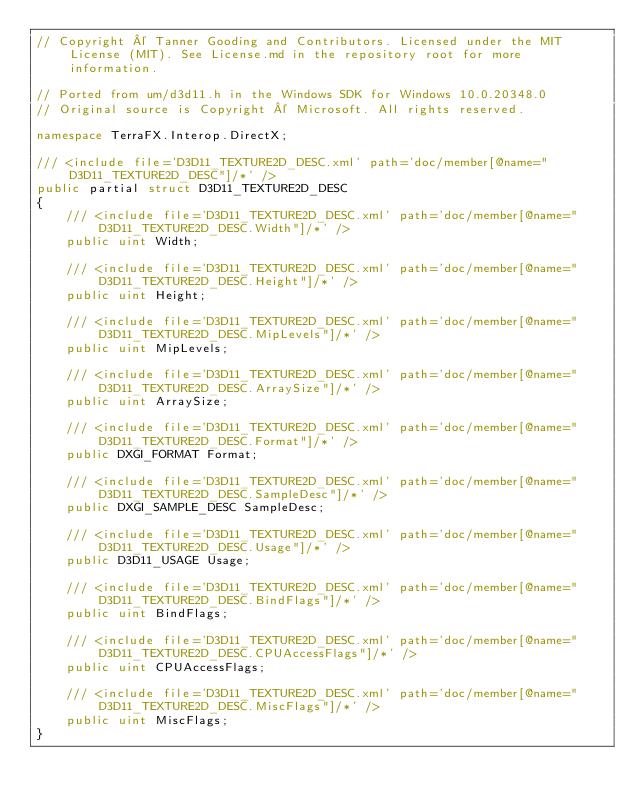Convert code to text. <code><loc_0><loc_0><loc_500><loc_500><_C#_>// Copyright © Tanner Gooding and Contributors. Licensed under the MIT License (MIT). See License.md in the repository root for more information.

// Ported from um/d3d11.h in the Windows SDK for Windows 10.0.20348.0
// Original source is Copyright © Microsoft. All rights reserved.

namespace TerraFX.Interop.DirectX;

/// <include file='D3D11_TEXTURE2D_DESC.xml' path='doc/member[@name="D3D11_TEXTURE2D_DESC"]/*' />
public partial struct D3D11_TEXTURE2D_DESC
{
    /// <include file='D3D11_TEXTURE2D_DESC.xml' path='doc/member[@name="D3D11_TEXTURE2D_DESC.Width"]/*' />
    public uint Width;

    /// <include file='D3D11_TEXTURE2D_DESC.xml' path='doc/member[@name="D3D11_TEXTURE2D_DESC.Height"]/*' />
    public uint Height;

    /// <include file='D3D11_TEXTURE2D_DESC.xml' path='doc/member[@name="D3D11_TEXTURE2D_DESC.MipLevels"]/*' />
    public uint MipLevels;

    /// <include file='D3D11_TEXTURE2D_DESC.xml' path='doc/member[@name="D3D11_TEXTURE2D_DESC.ArraySize"]/*' />
    public uint ArraySize;

    /// <include file='D3D11_TEXTURE2D_DESC.xml' path='doc/member[@name="D3D11_TEXTURE2D_DESC.Format"]/*' />
    public DXGI_FORMAT Format;

    /// <include file='D3D11_TEXTURE2D_DESC.xml' path='doc/member[@name="D3D11_TEXTURE2D_DESC.SampleDesc"]/*' />
    public DXGI_SAMPLE_DESC SampleDesc;

    /// <include file='D3D11_TEXTURE2D_DESC.xml' path='doc/member[@name="D3D11_TEXTURE2D_DESC.Usage"]/*' />
    public D3D11_USAGE Usage;

    /// <include file='D3D11_TEXTURE2D_DESC.xml' path='doc/member[@name="D3D11_TEXTURE2D_DESC.BindFlags"]/*' />
    public uint BindFlags;

    /// <include file='D3D11_TEXTURE2D_DESC.xml' path='doc/member[@name="D3D11_TEXTURE2D_DESC.CPUAccessFlags"]/*' />
    public uint CPUAccessFlags;

    /// <include file='D3D11_TEXTURE2D_DESC.xml' path='doc/member[@name="D3D11_TEXTURE2D_DESC.MiscFlags"]/*' />
    public uint MiscFlags;
}
</code> 